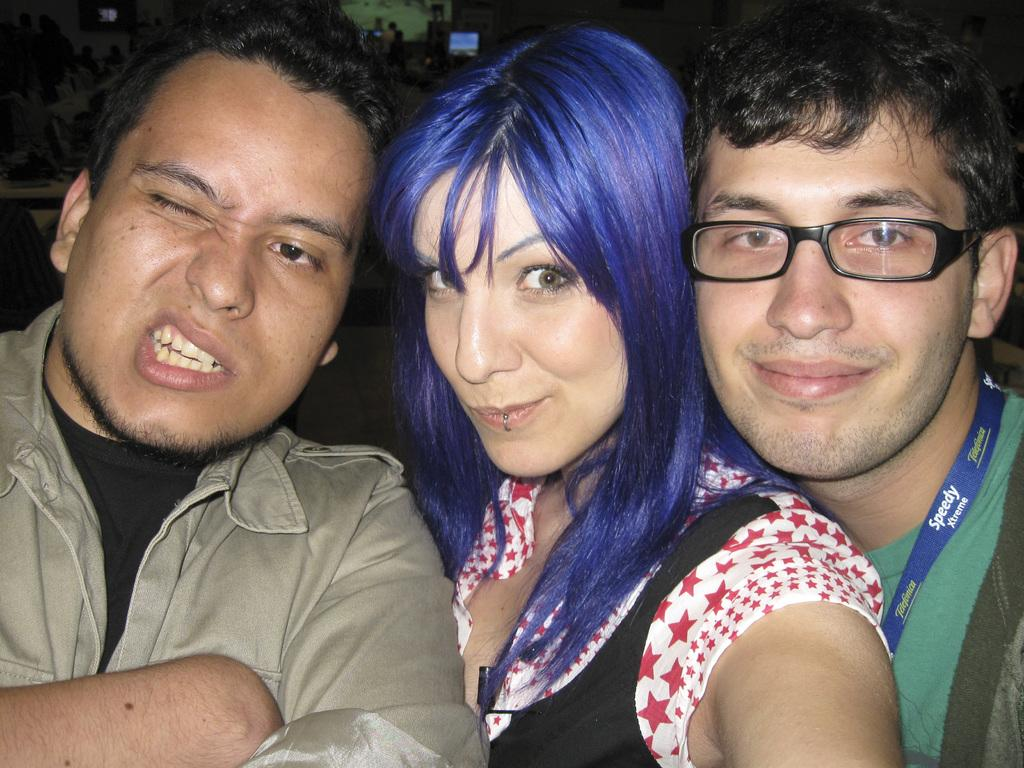How many people are present in the image? There is a woman and two men in the image, making a total of three people. What is visible at the top of the image? At the top of the image, there are people, a monitor, and a wall visible. Can you describe the people at the top of the image? Unfortunately, the facts provided do not give enough information to describe the people at the top of the image. How many houses are visible in the image? There is no house visible in the image. What is the fifth person doing in the image? There are only three people present in the image, so there is no fifth person to describe. 